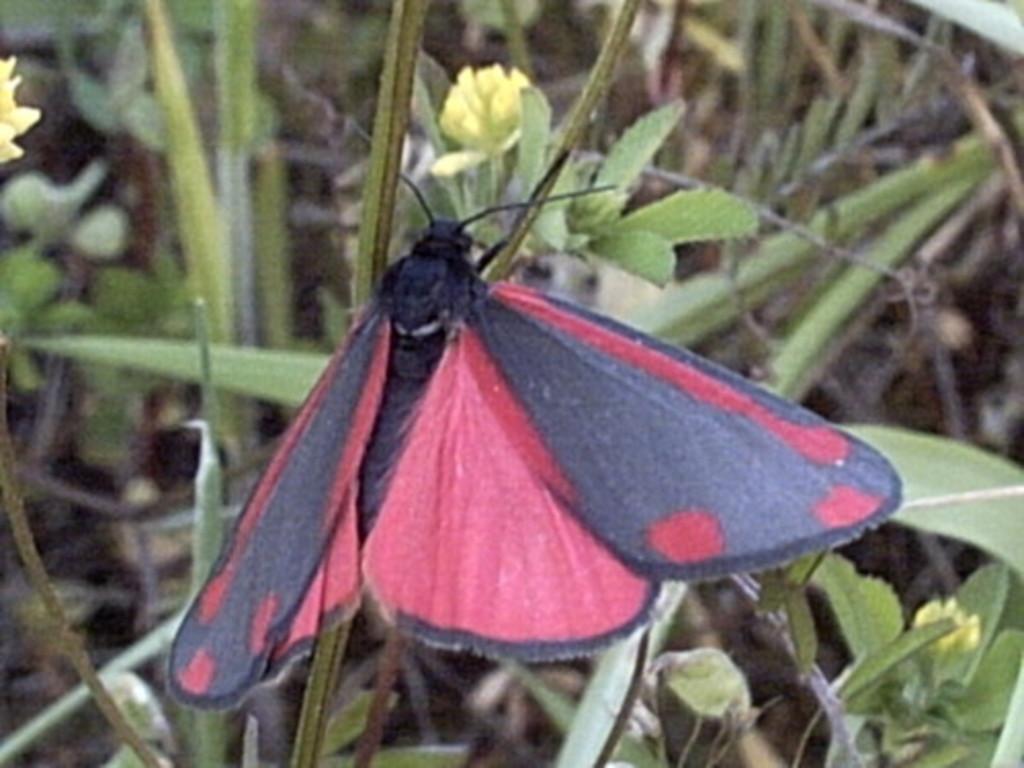In one or two sentences, can you explain what this image depicts? In the center of the image, we can see a butterfly and in the background, there are plants. 